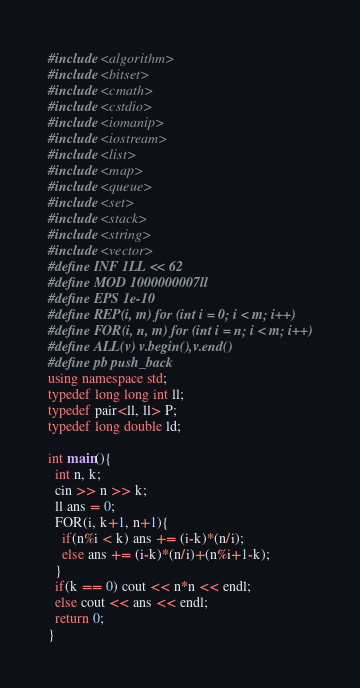Convert code to text. <code><loc_0><loc_0><loc_500><loc_500><_C++_>#include <algorithm>
#include <bitset>
#include <cmath>
#include <cstdio>
#include <iomanip>
#include <iostream>
#include <list>
#include <map>
#include <queue>
#include <set>
#include <stack>
#include <string>
#include <vector>
#define INF 1LL << 62
#define MOD 1000000007ll
#define EPS 1e-10
#define REP(i, m) for (int i = 0; i < m; i++)
#define FOR(i, n, m) for (int i = n; i < m; i++)
#define ALL(v) v.begin(),v.end() 
#define pb push_back
using namespace std;
typedef long long int ll;
typedef pair<ll, ll> P;
typedef long double ld;

int main(){
  int n, k;
  cin >> n >> k;
  ll ans = 0;
  FOR(i, k+1, n+1){
    if(n%i < k) ans += (i-k)*(n/i);
    else ans += (i-k)*(n/i)+(n%i+1-k);
  }
  if(k == 0) cout << n*n << endl;
  else cout << ans << endl;
  return 0;
}
</code> 